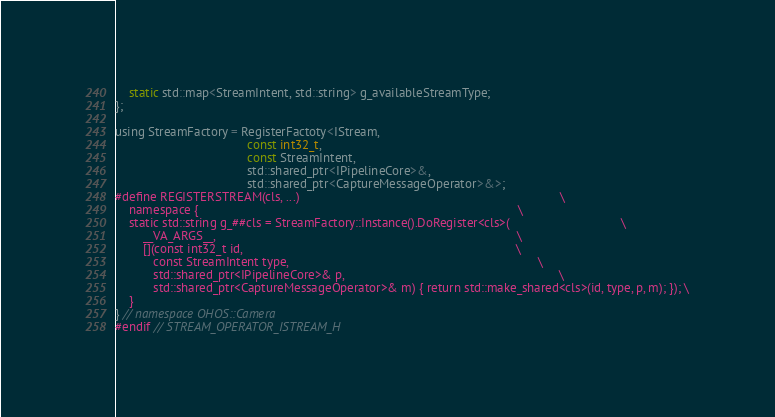<code> <loc_0><loc_0><loc_500><loc_500><_C_>    static std::map<StreamIntent, std::string> g_availableStreamType;
};

using StreamFactory = RegisterFactoty<IStream,
                                      const int32_t,
                                      const StreamIntent,
                                      std::shared_ptr<IPipelineCore>&,
                                      std::shared_ptr<CaptureMessageOperator>&>;
#define REGISTERSTREAM(cls, ...)                                                                           \
    namespace {                                                                                            \
    static std::string g_##cls = StreamFactory::Instance().DoRegister<cls>(                                \
        __VA_ARGS__,                                                                                       \
        [](const int32_t id,                                                                               \
           const StreamIntent type,                                                                        \
           std::shared_ptr<IPipelineCore>& p,                                                              \
           std::shared_ptr<CaptureMessageOperator>& m) { return std::make_shared<cls>(id, type, p, m); }); \
    }
} // namespace OHOS::Camera
#endif // STREAM_OPERATOR_ISTREAM_H
</code> 